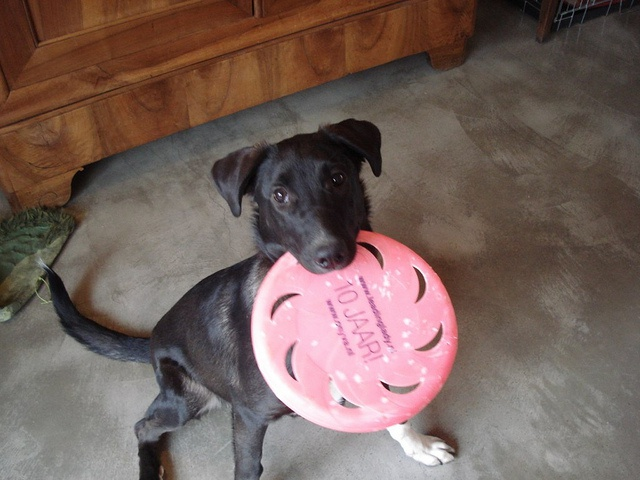Describe the objects in this image and their specific colors. I can see dog in maroon, black, gray, and darkgray tones and frisbee in maroon, pink, lightpink, and salmon tones in this image. 